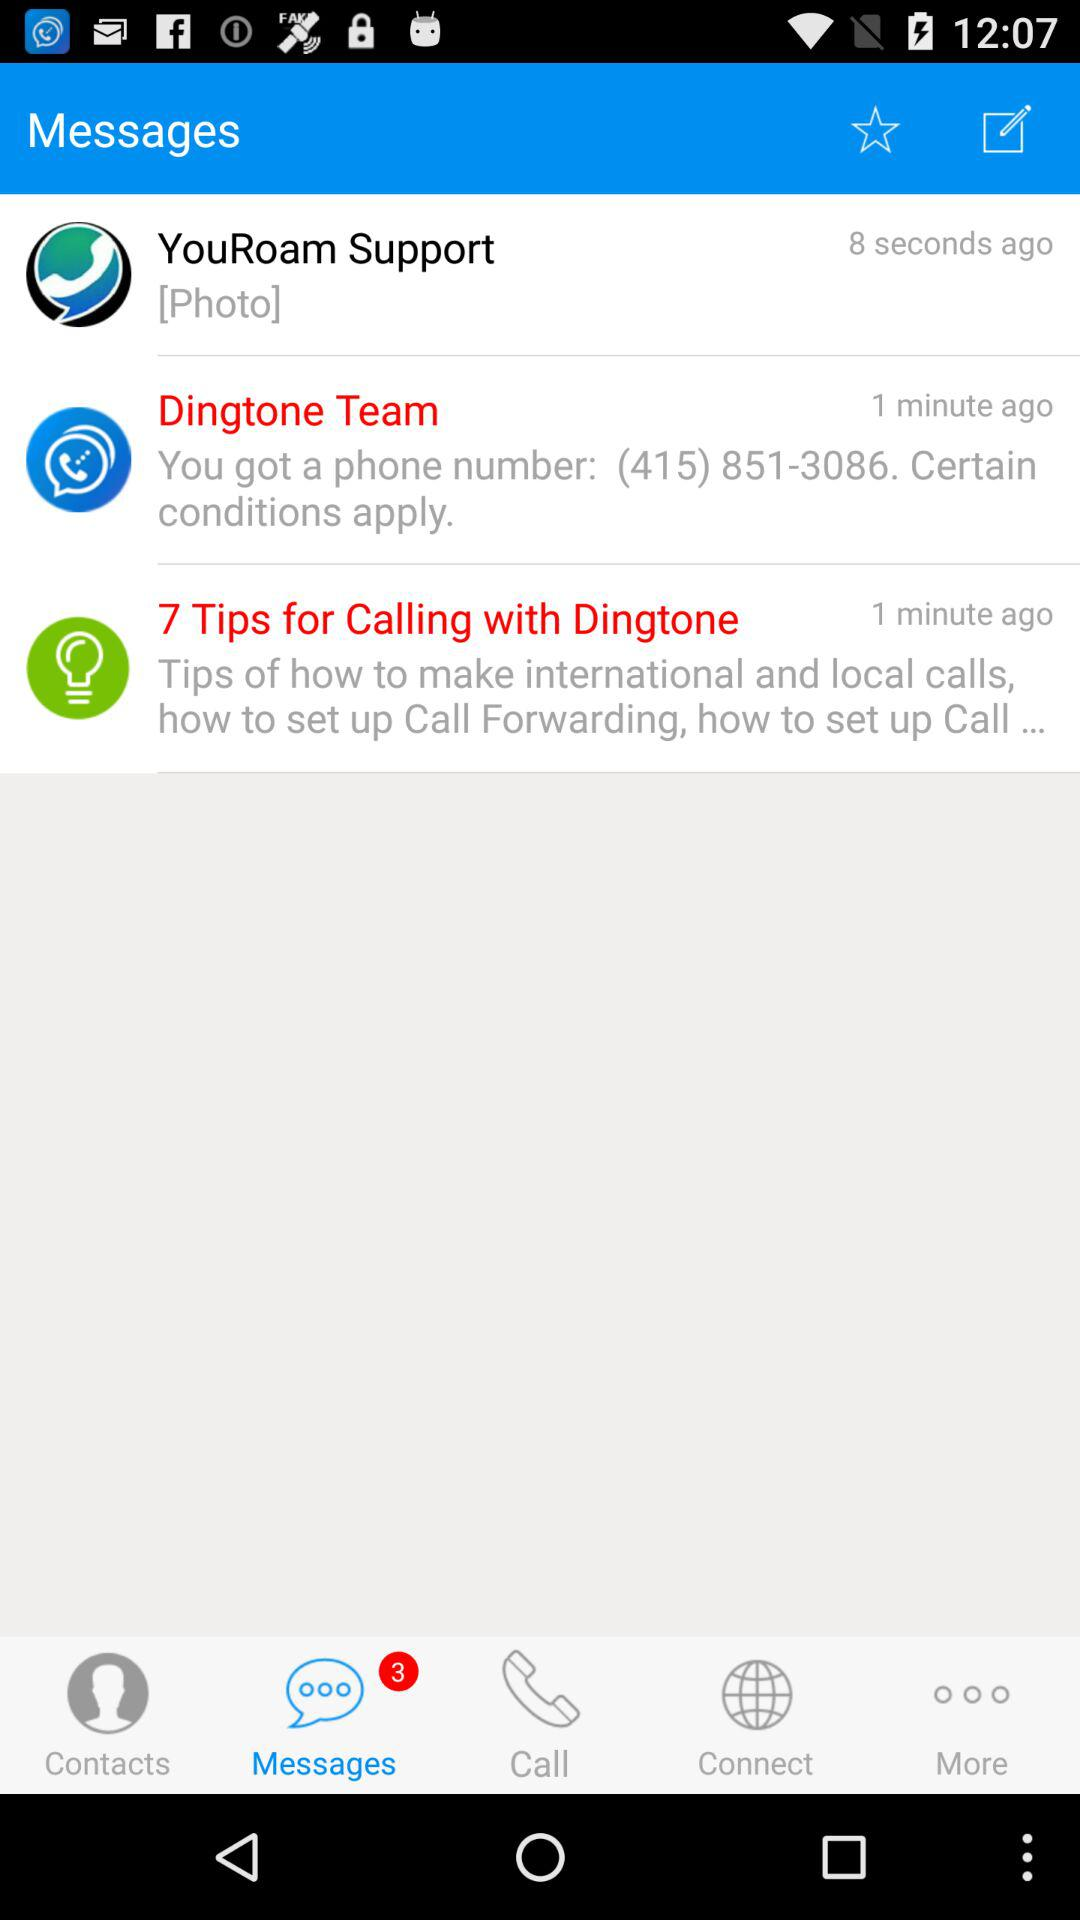How many minutes ago did "7 Tips for Calling with Dingtone" send the message? "7 Tips for Calling with Dingtone" sent the message 1 minute ago. 